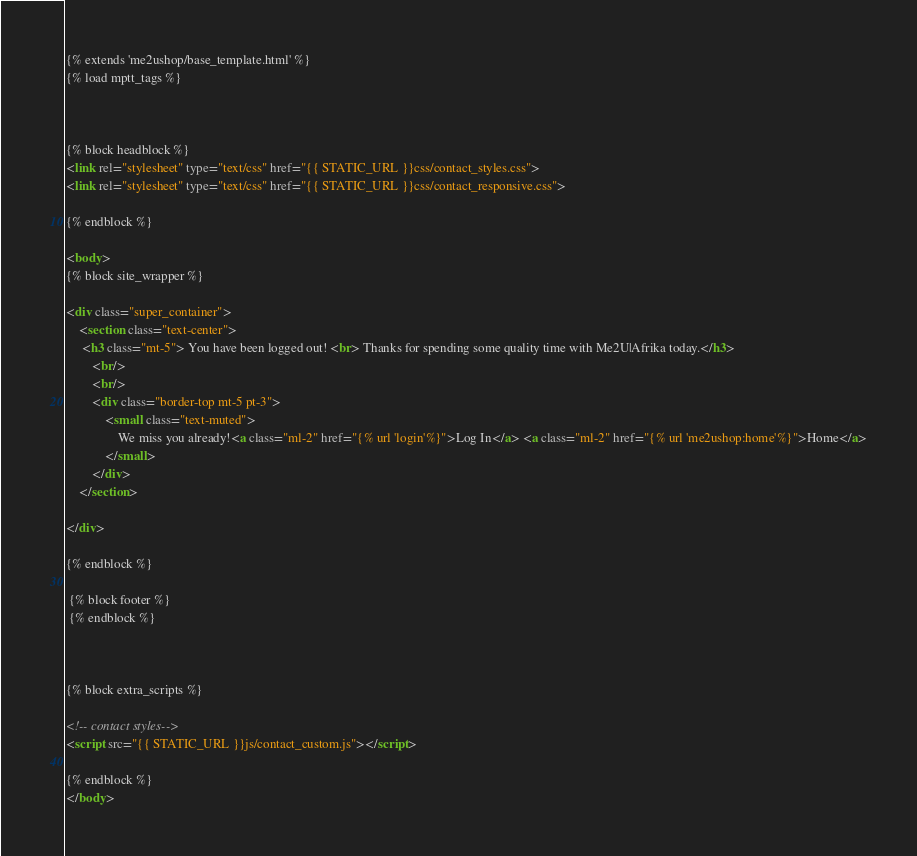Convert code to text. <code><loc_0><loc_0><loc_500><loc_500><_HTML_>{% extends 'me2ushop/base_template.html' %}
{% load mptt_tags %}



{% block headblock %}
<link rel="stylesheet" type="text/css" href="{{ STATIC_URL }}css/contact_styles.css">
<link rel="stylesheet" type="text/css" href="{{ STATIC_URL }}css/contact_responsive.css">

{% endblock %}

<body>
{% block site_wrapper %}

<div class="super_container">
    <section class="text-center">
     <h3 class="mt-5"> You have been logged out! <br> Thanks for spending some quality time with Me2U|Afrika today.</h3>
        <br/>
        <br/>
        <div class="border-top mt-5 pt-3">
            <small class="text-muted">
                We miss you already!<a class="ml-2" href="{% url 'login'%}">Log In</a> <a class="ml-2" href="{% url 'me2ushop:home'%}">Home</a>
            </small>
        </div>
    </section>

</div>

{% endblock %}

 {% block footer %}
 {% endblock %}



{% block extra_scripts %}

<!-- contact styles-->
<script src="{{ STATIC_URL }}js/contact_custom.js"></script>

{% endblock %}
</body>

</code> 